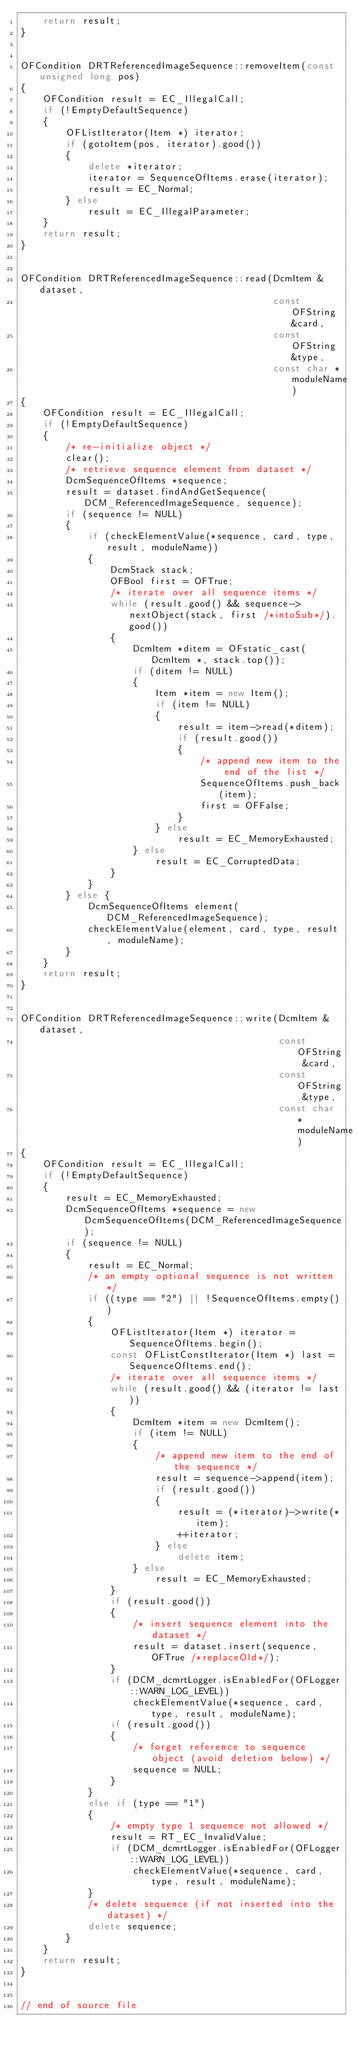Convert code to text. <code><loc_0><loc_0><loc_500><loc_500><_C++_>    return result;
}


OFCondition DRTReferencedImageSequence::removeItem(const unsigned long pos)
{
    OFCondition result = EC_IllegalCall;
    if (!EmptyDefaultSequence)
    {
        OFListIterator(Item *) iterator;
        if (gotoItem(pos, iterator).good())
        {
            delete *iterator;
            iterator = SequenceOfItems.erase(iterator);
            result = EC_Normal;
        } else
            result = EC_IllegalParameter;
    }
    return result;
}


OFCondition DRTReferencedImageSequence::read(DcmItem &dataset,
                                             const OFString &card,
                                             const OFString &type,
                                             const char *moduleName)
{
    OFCondition result = EC_IllegalCall;
    if (!EmptyDefaultSequence)
    {
        /* re-initialize object */
        clear();
        /* retrieve sequence element from dataset */
        DcmSequenceOfItems *sequence;
        result = dataset.findAndGetSequence(DCM_ReferencedImageSequence, sequence);
        if (sequence != NULL)
        {
            if (checkElementValue(*sequence, card, type, result, moduleName))
            {
                DcmStack stack;
                OFBool first = OFTrue;
                /* iterate over all sequence items */
                while (result.good() && sequence->nextObject(stack, first /*intoSub*/).good())
                {
                    DcmItem *ditem = OFstatic_cast(DcmItem *, stack.top());
                    if (ditem != NULL)
                    {
                        Item *item = new Item();
                        if (item != NULL)
                        {
                            result = item->read(*ditem);
                            if (result.good())
                            {
                                /* append new item to the end of the list */
                                SequenceOfItems.push_back(item);
                                first = OFFalse;
                            }
                        } else
                            result = EC_MemoryExhausted;
                    } else
                        result = EC_CorruptedData;
                }
            }
        } else {
            DcmSequenceOfItems element(DCM_ReferencedImageSequence);
            checkElementValue(element, card, type, result, moduleName);
        }
    }
    return result;
}


OFCondition DRTReferencedImageSequence::write(DcmItem &dataset,
                                              const OFString &card,
                                              const OFString &type,
                                              const char *moduleName)
{
    OFCondition result = EC_IllegalCall;
    if (!EmptyDefaultSequence)
    {
        result = EC_MemoryExhausted;
        DcmSequenceOfItems *sequence = new DcmSequenceOfItems(DCM_ReferencedImageSequence);
        if (sequence != NULL)
        {
            result = EC_Normal;
            /* an empty optional sequence is not written */
            if ((type == "2") || !SequenceOfItems.empty())
            {
                OFListIterator(Item *) iterator = SequenceOfItems.begin();
                const OFListConstIterator(Item *) last = SequenceOfItems.end();
                /* iterate over all sequence items */
                while (result.good() && (iterator != last))
                {
                    DcmItem *item = new DcmItem();
                    if (item != NULL)
                    {
                        /* append new item to the end of the sequence */
                        result = sequence->append(item);
                        if (result.good())
                        {
                            result = (*iterator)->write(*item);
                            ++iterator;
                        } else
                            delete item;
                    } else
                        result = EC_MemoryExhausted;
                }
                if (result.good())
                {
                    /* insert sequence element into the dataset */
                    result = dataset.insert(sequence, OFTrue /*replaceOld*/);
                }
                if (DCM_dcmrtLogger.isEnabledFor(OFLogger::WARN_LOG_LEVEL))
                    checkElementValue(*sequence, card, type, result, moduleName);
                if (result.good())
                {
                    /* forget reference to sequence object (avoid deletion below) */
                    sequence = NULL;
                }
            }
            else if (type == "1")
            {
                /* empty type 1 sequence not allowed */
                result = RT_EC_InvalidValue;
                if (DCM_dcmrtLogger.isEnabledFor(OFLogger::WARN_LOG_LEVEL))
                    checkElementValue(*sequence, card, type, result, moduleName);
            }
            /* delete sequence (if not inserted into the dataset) */
            delete sequence;
        }
    }
    return result;
}


// end of source file
</code> 